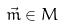Convert formula to latex. <formula><loc_0><loc_0><loc_500><loc_500>\vec { m } \in M</formula> 